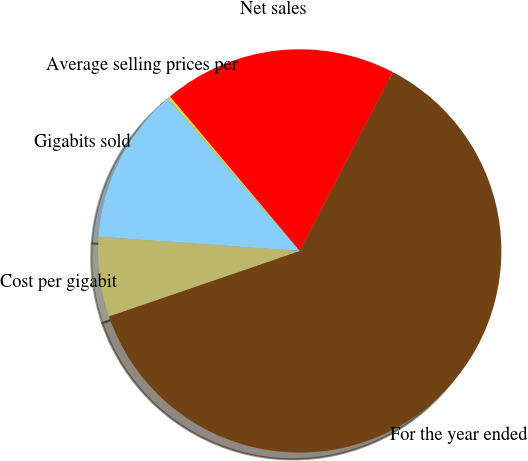<chart> <loc_0><loc_0><loc_500><loc_500><pie_chart><fcel>For the year ended<fcel>Net sales<fcel>Average selling prices per<fcel>Gigabits sold<fcel>Cost per gigabit<nl><fcel>62.11%<fcel>18.76%<fcel>0.19%<fcel>12.57%<fcel>6.38%<nl></chart> 